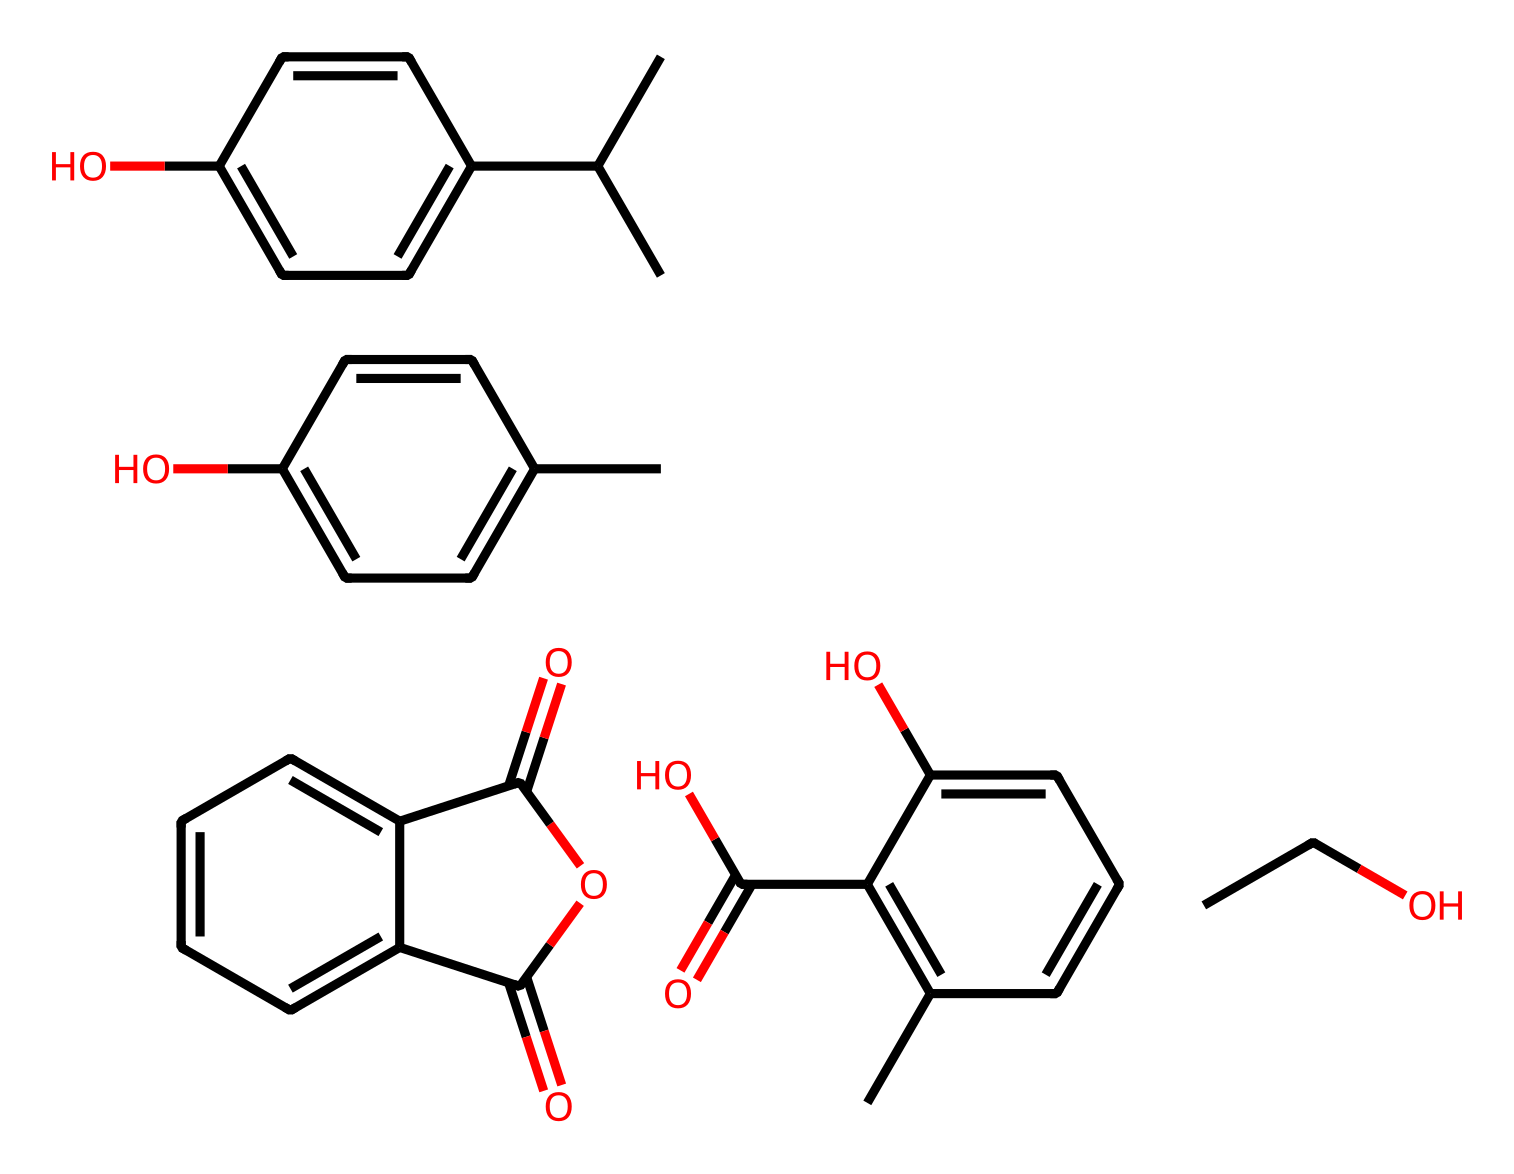how many carbon atoms are in the chemical structure? By analyzing the provided SMILES representation, you can count each carbon (C) symbol. In this case, there are multiple groups, and the total count of carbon atoms is 24.
Answer: 24 what is the molecular weight of absinthe? To find the molecular weight, you would need to consider the individual atomic weights of each element present: carbon, hydrogen, and oxygen. After performing the calculation based on the number of atoms from the SMILES structure, the total molecular weight of absinthe is approximately 338.39 g/mol.
Answer: 338.39 g/mol which functional groups are present in this chemical? The SMILES notation indicates the presence of functional groups such as hydroxyl (–OH) groups and ester (–COO–) groups. The aromatic rings also suggest potential phenolic compounds due to the multiple hydroxyl substitutions.
Answer: hydroxyl and ester what type of flavor profile is likely contributed by the aromatic rings in absinthe? The aromatic rings in absinthe are typically associated with herbal and complex flavors. The multiple substituents, including those reminiscent of phenolics, suggest a flavor profile that offers a mix of spicy, herbal, and slightly sweet notes, characteristic of absinthe.
Answer: herbal and complex how many rings does this chemical structure contain? The structure has several cyclic components indicated by the presence of "C1" and "C2" notations in the SMILES string, representing ring closures. Upon counting, there are 3 distinct rings in the structure.
Answer: 3 what is the significance of the presence of hydroxyl groups in absinthe? Hydroxyl groups (–OH) are important because they contribute to the solubility of the compound in water, affect its flavor profile, and can influence its pharmacological properties. More specifically, they play a role in the drink's bittersweet taste and potential health effects.
Answer: solubility and flavor influence how many double bonds are indicated in the chemical structure? Double bonds can be recognized in the SMILES by counting the "=" symbols. After reviewing the structure, you will find that there are 6 double bonds present within the chemical.
Answer: 6 